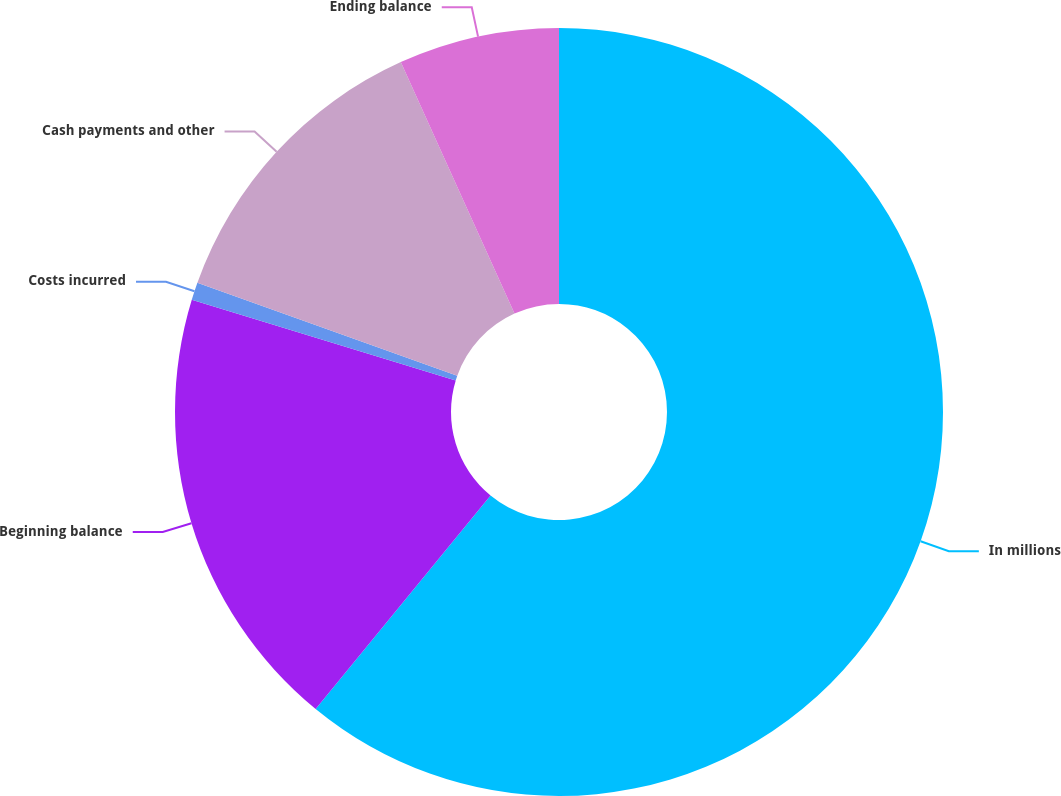<chart> <loc_0><loc_0><loc_500><loc_500><pie_chart><fcel>In millions<fcel>Beginning balance<fcel>Costs incurred<fcel>Cash payments and other<fcel>Ending balance<nl><fcel>60.93%<fcel>18.8%<fcel>0.74%<fcel>12.78%<fcel>6.76%<nl></chart> 